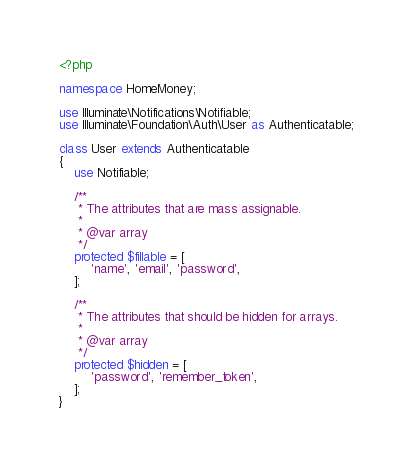Convert code to text. <code><loc_0><loc_0><loc_500><loc_500><_PHP_><?php

namespace HomeMoney;

use Illuminate\Notifications\Notifiable;
use Illuminate\Foundation\Auth\User as Authenticatable;

class User extends Authenticatable
{
    use Notifiable;

    /**
     * The attributes that are mass assignable.
     *
     * @var array
     */
    protected $fillable = [
        'name', 'email', 'password',
    ];

    /**
     * The attributes that should be hidden for arrays.
     *
     * @var array
     */
    protected $hidden = [
        'password', 'remember_token',
    ];
}
</code> 